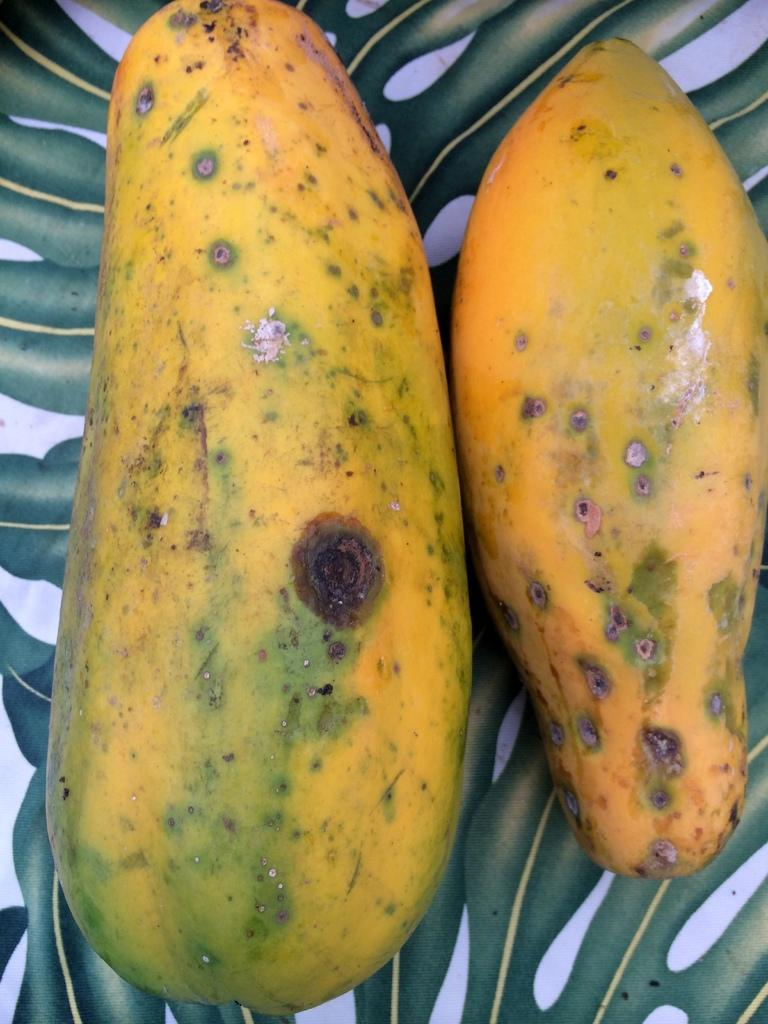What type of objects in the image resemble papayas? There are objects in the image that resemble papayas. What type of sidewalk can be seen in the image? There is no sidewalk present in the image; it only contains objects that resemble papayas. What form does the cast take in the image? There is no cast present in the image; it only contains objects that resemble papayas. 